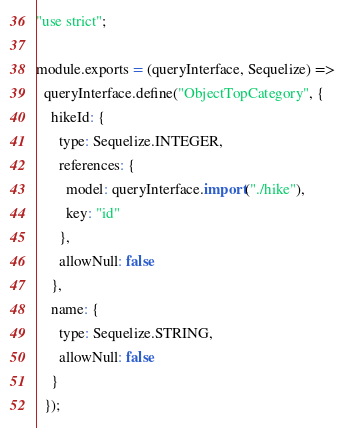Convert code to text. <code><loc_0><loc_0><loc_500><loc_500><_JavaScript_>"use strict";

module.exports = (queryInterface, Sequelize) =>
  queryInterface.define("ObjectTopCategory", {
    hikeId: {
      type: Sequelize.INTEGER,
      references: {
        model: queryInterface.import("./hike"),
        key: "id"
      },
      allowNull: false
    },
    name: {
      type: Sequelize.STRING,
      allowNull: false
    }
  });
</code> 